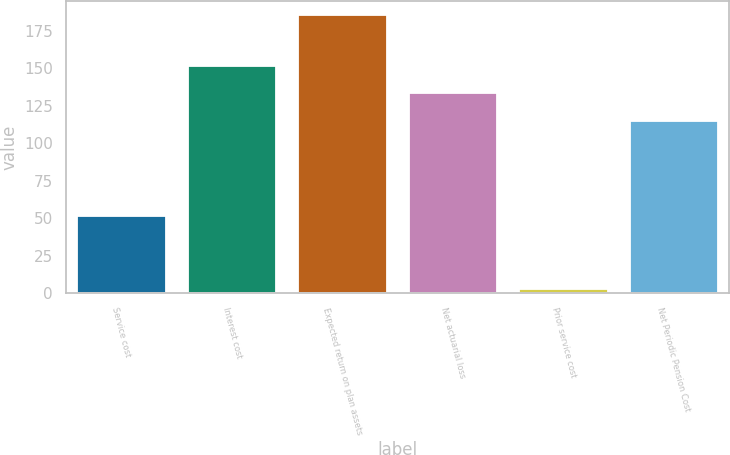Convert chart to OTSL. <chart><loc_0><loc_0><loc_500><loc_500><bar_chart><fcel>Service cost<fcel>Interest cost<fcel>Expected return on plan assets<fcel>Net actuarial loss<fcel>Prior service cost<fcel>Net Periodic Pension Cost<nl><fcel>51.8<fcel>151.6<fcel>185.4<fcel>133.35<fcel>2.9<fcel>115.1<nl></chart> 